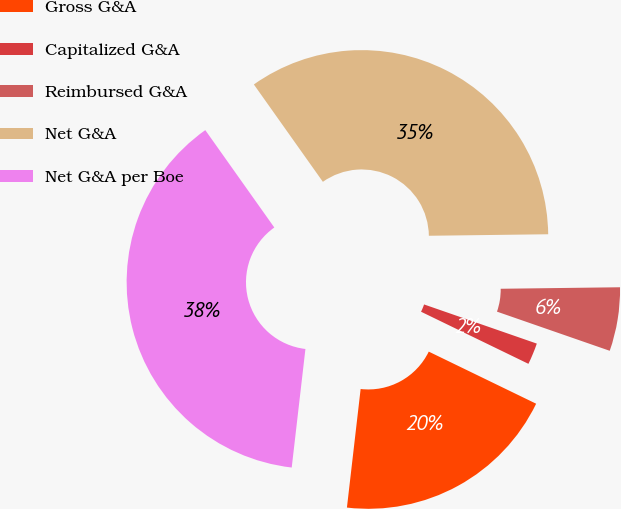Convert chart to OTSL. <chart><loc_0><loc_0><loc_500><loc_500><pie_chart><fcel>Gross G&A<fcel>Capitalized G&A<fcel>Reimbursed G&A<fcel>Net G&A<fcel>Net G&A per Boe<nl><fcel>19.64%<fcel>1.87%<fcel>5.52%<fcel>34.61%<fcel>38.35%<nl></chart> 